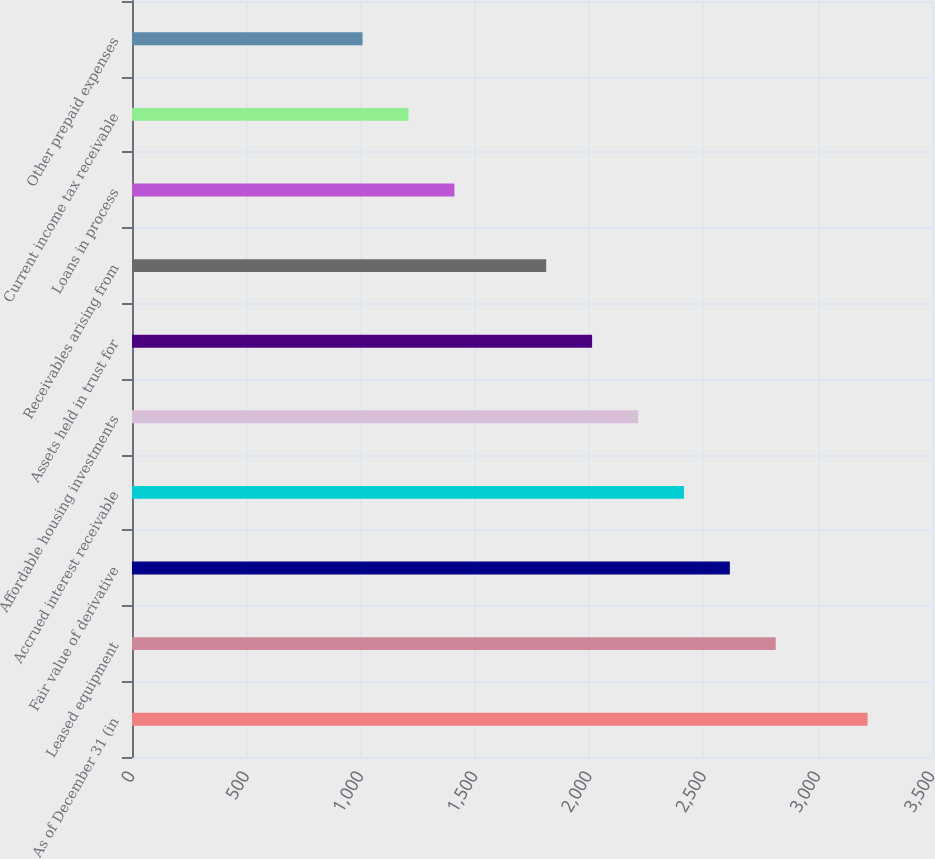<chart> <loc_0><loc_0><loc_500><loc_500><bar_chart><fcel>As of December 31 (in<fcel>Leased equipment<fcel>Fair value of derivative<fcel>Accrued interest receivable<fcel>Affordable housing investments<fcel>Assets held in trust for<fcel>Receivables arising from<fcel>Loans in process<fcel>Current income tax receivable<fcel>Other prepaid expenses<nl><fcel>3218.1<fcel>2816.4<fcel>2615.55<fcel>2414.7<fcel>2213.85<fcel>2013<fcel>1812.15<fcel>1410.45<fcel>1209.6<fcel>1008.75<nl></chart> 